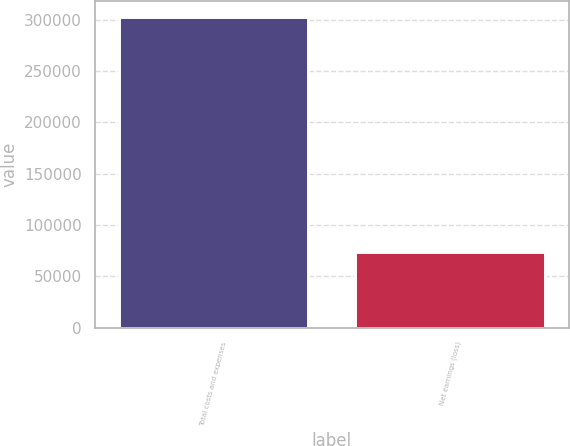Convert chart. <chart><loc_0><loc_0><loc_500><loc_500><bar_chart><fcel>Total costs and expenses<fcel>Net earnings (loss)<nl><fcel>302738<fcel>73434<nl></chart> 